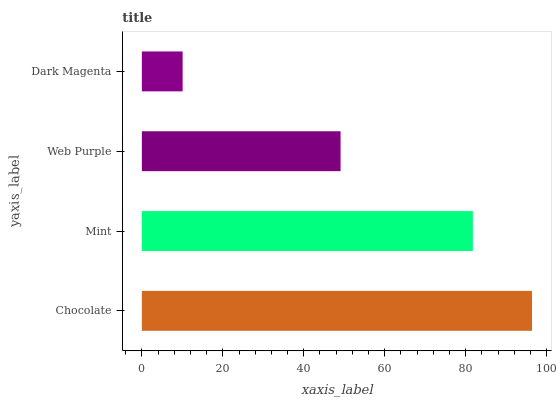Is Dark Magenta the minimum?
Answer yes or no. Yes. Is Chocolate the maximum?
Answer yes or no. Yes. Is Mint the minimum?
Answer yes or no. No. Is Mint the maximum?
Answer yes or no. No. Is Chocolate greater than Mint?
Answer yes or no. Yes. Is Mint less than Chocolate?
Answer yes or no. Yes. Is Mint greater than Chocolate?
Answer yes or no. No. Is Chocolate less than Mint?
Answer yes or no. No. Is Mint the high median?
Answer yes or no. Yes. Is Web Purple the low median?
Answer yes or no. Yes. Is Web Purple the high median?
Answer yes or no. No. Is Dark Magenta the low median?
Answer yes or no. No. 